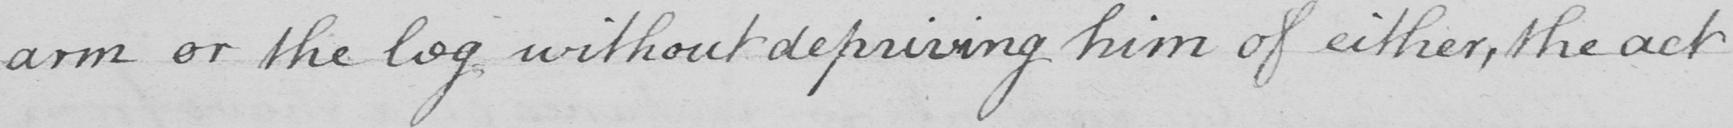Can you read and transcribe this handwriting? arm or the leg without depriving him of either, the act 